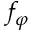Convert formula to latex. <formula><loc_0><loc_0><loc_500><loc_500>f _ { \varphi }</formula> 